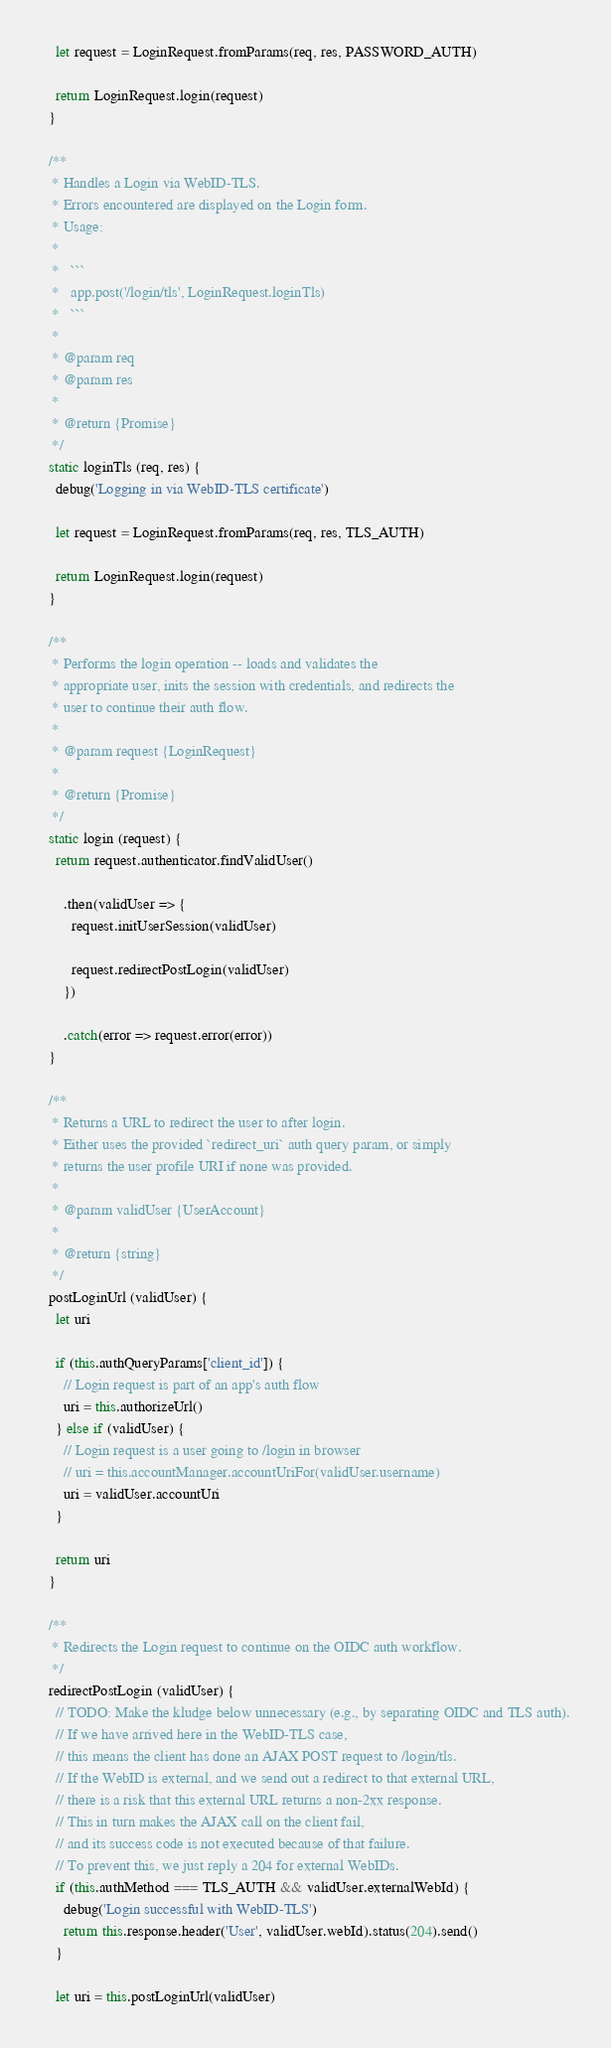<code> <loc_0><loc_0><loc_500><loc_500><_JavaScript_>
    let request = LoginRequest.fromParams(req, res, PASSWORD_AUTH)

    return LoginRequest.login(request)
  }

  /**
   * Handles a Login via WebID-TLS.
   * Errors encountered are displayed on the Login form.
   * Usage:
   *
   *   ```
   *   app.post('/login/tls', LoginRequest.loginTls)
   *   ```
   *
   * @param req
   * @param res
   *
   * @return {Promise}
   */
  static loginTls (req, res) {
    debug('Logging in via WebID-TLS certificate')

    let request = LoginRequest.fromParams(req, res, TLS_AUTH)

    return LoginRequest.login(request)
  }

  /**
   * Performs the login operation -- loads and validates the
   * appropriate user, inits the session with credentials, and redirects the
   * user to continue their auth flow.
   *
   * @param request {LoginRequest}
   *
   * @return {Promise}
   */
  static login (request) {
    return request.authenticator.findValidUser()

      .then(validUser => {
        request.initUserSession(validUser)

        request.redirectPostLogin(validUser)
      })

      .catch(error => request.error(error))
  }

  /**
   * Returns a URL to redirect the user to after login.
   * Either uses the provided `redirect_uri` auth query param, or simply
   * returns the user profile URI if none was provided.
   *
   * @param validUser {UserAccount}
   *
   * @return {string}
   */
  postLoginUrl (validUser) {
    let uri

    if (this.authQueryParams['client_id']) {
      // Login request is part of an app's auth flow
      uri = this.authorizeUrl()
    } else if (validUser) {
      // Login request is a user going to /login in browser
      // uri = this.accountManager.accountUriFor(validUser.username)
      uri = validUser.accountUri
    }

    return uri
  }

  /**
   * Redirects the Login request to continue on the OIDC auth workflow.
   */
  redirectPostLogin (validUser) {
    // TODO: Make the kludge below unnecessary (e.g., by separating OIDC and TLS auth).
    // If we have arrived here in the WebID-TLS case,
    // this means the client has done an AJAX POST request to /login/tls.
    // If the WebID is external, and we send out a redirect to that external URL,
    // there is a risk that this external URL returns a non-2xx response.
    // This in turn makes the AJAX call on the client fail,
    // and its success code is not executed because of that failure.
    // To prevent this, we just reply a 204 for external WebIDs.
    if (this.authMethod === TLS_AUTH && validUser.externalWebId) {
      debug('Login successful with WebID-TLS')
      return this.response.header('User', validUser.webId).status(204).send()
    }

    let uri = this.postLoginUrl(validUser)</code> 